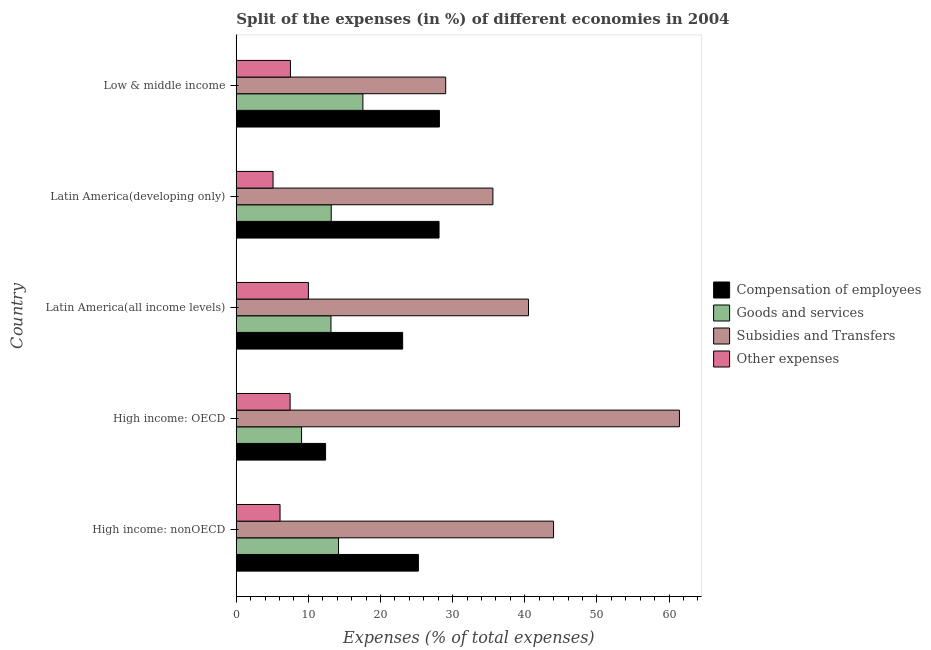How many different coloured bars are there?
Provide a succinct answer. 4. Are the number of bars per tick equal to the number of legend labels?
Offer a terse response. Yes. Are the number of bars on each tick of the Y-axis equal?
Your answer should be compact. Yes. How many bars are there on the 2nd tick from the bottom?
Keep it short and to the point. 4. What is the label of the 3rd group of bars from the top?
Your answer should be very brief. Latin America(all income levels). In how many cases, is the number of bars for a given country not equal to the number of legend labels?
Offer a very short reply. 0. What is the percentage of amount spent on compensation of employees in Low & middle income?
Offer a very short reply. 28.17. Across all countries, what is the maximum percentage of amount spent on compensation of employees?
Your answer should be compact. 28.17. Across all countries, what is the minimum percentage of amount spent on goods and services?
Ensure brevity in your answer.  9.05. In which country was the percentage of amount spent on compensation of employees minimum?
Your answer should be compact. High income: OECD. What is the total percentage of amount spent on goods and services in the graph?
Offer a very short reply. 67.09. What is the difference between the percentage of amount spent on goods and services in High income: OECD and that in Latin America(developing only)?
Offer a very short reply. -4.11. What is the difference between the percentage of amount spent on subsidies in High income: OECD and the percentage of amount spent on goods and services in Latin America(all income levels)?
Provide a short and direct response. 48.31. What is the average percentage of amount spent on compensation of employees per country?
Ensure brevity in your answer.  23.4. What is the difference between the percentage of amount spent on other expenses and percentage of amount spent on compensation of employees in High income: OECD?
Make the answer very short. -4.92. In how many countries, is the percentage of amount spent on other expenses greater than 52 %?
Your answer should be very brief. 0. What is the ratio of the percentage of amount spent on subsidies in High income: OECD to that in High income: nonOECD?
Offer a terse response. 1.4. What is the difference between the highest and the second highest percentage of amount spent on other expenses?
Make the answer very short. 2.49. What is the difference between the highest and the lowest percentage of amount spent on compensation of employees?
Keep it short and to the point. 15.78. In how many countries, is the percentage of amount spent on other expenses greater than the average percentage of amount spent on other expenses taken over all countries?
Your response must be concise. 3. Is it the case that in every country, the sum of the percentage of amount spent on subsidies and percentage of amount spent on compensation of employees is greater than the sum of percentage of amount spent on goods and services and percentage of amount spent on other expenses?
Provide a short and direct response. Yes. What does the 3rd bar from the top in Low & middle income represents?
Provide a succinct answer. Goods and services. What does the 2nd bar from the bottom in High income: nonOECD represents?
Make the answer very short. Goods and services. Are all the bars in the graph horizontal?
Provide a short and direct response. Yes. What is the difference between two consecutive major ticks on the X-axis?
Your response must be concise. 10. Are the values on the major ticks of X-axis written in scientific E-notation?
Ensure brevity in your answer.  No. Does the graph contain any zero values?
Provide a short and direct response. No. Does the graph contain grids?
Your response must be concise. No. Where does the legend appear in the graph?
Ensure brevity in your answer.  Center right. How many legend labels are there?
Make the answer very short. 4. How are the legend labels stacked?
Offer a very short reply. Vertical. What is the title of the graph?
Provide a short and direct response. Split of the expenses (in %) of different economies in 2004. Does "UNDP" appear as one of the legend labels in the graph?
Your response must be concise. No. What is the label or title of the X-axis?
Your answer should be compact. Expenses (% of total expenses). What is the Expenses (% of total expenses) in Compensation of employees in High income: nonOECD?
Make the answer very short. 25.25. What is the Expenses (% of total expenses) of Goods and services in High income: nonOECD?
Provide a short and direct response. 14.18. What is the Expenses (% of total expenses) in Subsidies and Transfers in High income: nonOECD?
Ensure brevity in your answer.  43.99. What is the Expenses (% of total expenses) of Other expenses in High income: nonOECD?
Offer a very short reply. 6.07. What is the Expenses (% of total expenses) of Compensation of employees in High income: OECD?
Ensure brevity in your answer.  12.39. What is the Expenses (% of total expenses) in Goods and services in High income: OECD?
Make the answer very short. 9.05. What is the Expenses (% of total expenses) in Subsidies and Transfers in High income: OECD?
Offer a terse response. 61.44. What is the Expenses (% of total expenses) in Other expenses in High income: OECD?
Make the answer very short. 7.47. What is the Expenses (% of total expenses) of Compensation of employees in Latin America(all income levels)?
Your answer should be compact. 23.07. What is the Expenses (% of total expenses) of Goods and services in Latin America(all income levels)?
Offer a terse response. 13.13. What is the Expenses (% of total expenses) in Subsidies and Transfers in Latin America(all income levels)?
Give a very brief answer. 40.52. What is the Expenses (% of total expenses) in Other expenses in Latin America(all income levels)?
Give a very brief answer. 10. What is the Expenses (% of total expenses) in Compensation of employees in Latin America(developing only)?
Your answer should be very brief. 28.12. What is the Expenses (% of total expenses) in Goods and services in Latin America(developing only)?
Offer a very short reply. 13.17. What is the Expenses (% of total expenses) in Subsidies and Transfers in Latin America(developing only)?
Your response must be concise. 35.58. What is the Expenses (% of total expenses) of Other expenses in Latin America(developing only)?
Give a very brief answer. 5.1. What is the Expenses (% of total expenses) in Compensation of employees in Low & middle income?
Ensure brevity in your answer.  28.17. What is the Expenses (% of total expenses) in Goods and services in Low & middle income?
Your answer should be very brief. 17.56. What is the Expenses (% of total expenses) in Subsidies and Transfers in Low & middle income?
Your response must be concise. 29.04. What is the Expenses (% of total expenses) of Other expenses in Low & middle income?
Provide a succinct answer. 7.51. Across all countries, what is the maximum Expenses (% of total expenses) in Compensation of employees?
Provide a succinct answer. 28.17. Across all countries, what is the maximum Expenses (% of total expenses) of Goods and services?
Provide a short and direct response. 17.56. Across all countries, what is the maximum Expenses (% of total expenses) in Subsidies and Transfers?
Provide a short and direct response. 61.44. Across all countries, what is the maximum Expenses (% of total expenses) of Other expenses?
Your answer should be compact. 10. Across all countries, what is the minimum Expenses (% of total expenses) of Compensation of employees?
Your answer should be compact. 12.39. Across all countries, what is the minimum Expenses (% of total expenses) of Goods and services?
Your response must be concise. 9.05. Across all countries, what is the minimum Expenses (% of total expenses) of Subsidies and Transfers?
Your answer should be compact. 29.04. Across all countries, what is the minimum Expenses (% of total expenses) of Other expenses?
Offer a terse response. 5.1. What is the total Expenses (% of total expenses) of Compensation of employees in the graph?
Your answer should be very brief. 116.99. What is the total Expenses (% of total expenses) in Goods and services in the graph?
Keep it short and to the point. 67.09. What is the total Expenses (% of total expenses) of Subsidies and Transfers in the graph?
Provide a short and direct response. 210.57. What is the total Expenses (% of total expenses) of Other expenses in the graph?
Keep it short and to the point. 36.16. What is the difference between the Expenses (% of total expenses) in Compensation of employees in High income: nonOECD and that in High income: OECD?
Your answer should be very brief. 12.87. What is the difference between the Expenses (% of total expenses) of Goods and services in High income: nonOECD and that in High income: OECD?
Keep it short and to the point. 5.12. What is the difference between the Expenses (% of total expenses) of Subsidies and Transfers in High income: nonOECD and that in High income: OECD?
Give a very brief answer. -17.45. What is the difference between the Expenses (% of total expenses) of Other expenses in High income: nonOECD and that in High income: OECD?
Give a very brief answer. -1.4. What is the difference between the Expenses (% of total expenses) of Compensation of employees in High income: nonOECD and that in Latin America(all income levels)?
Your response must be concise. 2.18. What is the difference between the Expenses (% of total expenses) of Goods and services in High income: nonOECD and that in Latin America(all income levels)?
Offer a terse response. 1.05. What is the difference between the Expenses (% of total expenses) in Subsidies and Transfers in High income: nonOECD and that in Latin America(all income levels)?
Ensure brevity in your answer.  3.47. What is the difference between the Expenses (% of total expenses) of Other expenses in High income: nonOECD and that in Latin America(all income levels)?
Give a very brief answer. -3.93. What is the difference between the Expenses (% of total expenses) in Compensation of employees in High income: nonOECD and that in Latin America(developing only)?
Keep it short and to the point. -2.86. What is the difference between the Expenses (% of total expenses) in Goods and services in High income: nonOECD and that in Latin America(developing only)?
Ensure brevity in your answer.  1.01. What is the difference between the Expenses (% of total expenses) of Subsidies and Transfers in High income: nonOECD and that in Latin America(developing only)?
Provide a succinct answer. 8.41. What is the difference between the Expenses (% of total expenses) of Other expenses in High income: nonOECD and that in Latin America(developing only)?
Make the answer very short. 0.97. What is the difference between the Expenses (% of total expenses) in Compensation of employees in High income: nonOECD and that in Low & middle income?
Your response must be concise. -2.91. What is the difference between the Expenses (% of total expenses) of Goods and services in High income: nonOECD and that in Low & middle income?
Keep it short and to the point. -3.38. What is the difference between the Expenses (% of total expenses) in Subsidies and Transfers in High income: nonOECD and that in Low & middle income?
Make the answer very short. 14.95. What is the difference between the Expenses (% of total expenses) of Other expenses in High income: nonOECD and that in Low & middle income?
Your answer should be very brief. -1.44. What is the difference between the Expenses (% of total expenses) of Compensation of employees in High income: OECD and that in Latin America(all income levels)?
Keep it short and to the point. -10.69. What is the difference between the Expenses (% of total expenses) in Goods and services in High income: OECD and that in Latin America(all income levels)?
Ensure brevity in your answer.  -4.08. What is the difference between the Expenses (% of total expenses) in Subsidies and Transfers in High income: OECD and that in Latin America(all income levels)?
Your response must be concise. 20.93. What is the difference between the Expenses (% of total expenses) of Other expenses in High income: OECD and that in Latin America(all income levels)?
Keep it short and to the point. -2.53. What is the difference between the Expenses (% of total expenses) in Compensation of employees in High income: OECD and that in Latin America(developing only)?
Your answer should be very brief. -15.73. What is the difference between the Expenses (% of total expenses) in Goods and services in High income: OECD and that in Latin America(developing only)?
Ensure brevity in your answer.  -4.11. What is the difference between the Expenses (% of total expenses) in Subsidies and Transfers in High income: OECD and that in Latin America(developing only)?
Offer a very short reply. 25.86. What is the difference between the Expenses (% of total expenses) of Other expenses in High income: OECD and that in Latin America(developing only)?
Ensure brevity in your answer.  2.37. What is the difference between the Expenses (% of total expenses) in Compensation of employees in High income: OECD and that in Low & middle income?
Keep it short and to the point. -15.78. What is the difference between the Expenses (% of total expenses) of Goods and services in High income: OECD and that in Low & middle income?
Offer a terse response. -8.5. What is the difference between the Expenses (% of total expenses) of Subsidies and Transfers in High income: OECD and that in Low & middle income?
Provide a succinct answer. 32.41. What is the difference between the Expenses (% of total expenses) of Other expenses in High income: OECD and that in Low & middle income?
Provide a succinct answer. -0.04. What is the difference between the Expenses (% of total expenses) of Compensation of employees in Latin America(all income levels) and that in Latin America(developing only)?
Provide a succinct answer. -5.04. What is the difference between the Expenses (% of total expenses) in Goods and services in Latin America(all income levels) and that in Latin America(developing only)?
Offer a terse response. -0.04. What is the difference between the Expenses (% of total expenses) in Subsidies and Transfers in Latin America(all income levels) and that in Latin America(developing only)?
Your response must be concise. 4.94. What is the difference between the Expenses (% of total expenses) in Other expenses in Latin America(all income levels) and that in Latin America(developing only)?
Your answer should be compact. 4.9. What is the difference between the Expenses (% of total expenses) of Compensation of employees in Latin America(all income levels) and that in Low & middle income?
Your answer should be compact. -5.09. What is the difference between the Expenses (% of total expenses) in Goods and services in Latin America(all income levels) and that in Low & middle income?
Your answer should be compact. -4.43. What is the difference between the Expenses (% of total expenses) in Subsidies and Transfers in Latin America(all income levels) and that in Low & middle income?
Your answer should be very brief. 11.48. What is the difference between the Expenses (% of total expenses) of Other expenses in Latin America(all income levels) and that in Low & middle income?
Offer a very short reply. 2.49. What is the difference between the Expenses (% of total expenses) in Compensation of employees in Latin America(developing only) and that in Low & middle income?
Your answer should be compact. -0.05. What is the difference between the Expenses (% of total expenses) in Goods and services in Latin America(developing only) and that in Low & middle income?
Your answer should be very brief. -4.39. What is the difference between the Expenses (% of total expenses) in Subsidies and Transfers in Latin America(developing only) and that in Low & middle income?
Offer a very short reply. 6.55. What is the difference between the Expenses (% of total expenses) in Other expenses in Latin America(developing only) and that in Low & middle income?
Your answer should be very brief. -2.41. What is the difference between the Expenses (% of total expenses) of Compensation of employees in High income: nonOECD and the Expenses (% of total expenses) of Goods and services in High income: OECD?
Your answer should be compact. 16.2. What is the difference between the Expenses (% of total expenses) in Compensation of employees in High income: nonOECD and the Expenses (% of total expenses) in Subsidies and Transfers in High income: OECD?
Ensure brevity in your answer.  -36.19. What is the difference between the Expenses (% of total expenses) in Compensation of employees in High income: nonOECD and the Expenses (% of total expenses) in Other expenses in High income: OECD?
Provide a succinct answer. 17.78. What is the difference between the Expenses (% of total expenses) in Goods and services in High income: nonOECD and the Expenses (% of total expenses) in Subsidies and Transfers in High income: OECD?
Your answer should be compact. -47.27. What is the difference between the Expenses (% of total expenses) of Goods and services in High income: nonOECD and the Expenses (% of total expenses) of Other expenses in High income: OECD?
Your response must be concise. 6.71. What is the difference between the Expenses (% of total expenses) in Subsidies and Transfers in High income: nonOECD and the Expenses (% of total expenses) in Other expenses in High income: OECD?
Give a very brief answer. 36.52. What is the difference between the Expenses (% of total expenses) in Compensation of employees in High income: nonOECD and the Expenses (% of total expenses) in Goods and services in Latin America(all income levels)?
Offer a terse response. 12.12. What is the difference between the Expenses (% of total expenses) of Compensation of employees in High income: nonOECD and the Expenses (% of total expenses) of Subsidies and Transfers in Latin America(all income levels)?
Provide a succinct answer. -15.27. What is the difference between the Expenses (% of total expenses) in Compensation of employees in High income: nonOECD and the Expenses (% of total expenses) in Other expenses in Latin America(all income levels)?
Make the answer very short. 15.25. What is the difference between the Expenses (% of total expenses) in Goods and services in High income: nonOECD and the Expenses (% of total expenses) in Subsidies and Transfers in Latin America(all income levels)?
Your answer should be compact. -26.34. What is the difference between the Expenses (% of total expenses) of Goods and services in High income: nonOECD and the Expenses (% of total expenses) of Other expenses in Latin America(all income levels)?
Your response must be concise. 4.18. What is the difference between the Expenses (% of total expenses) in Subsidies and Transfers in High income: nonOECD and the Expenses (% of total expenses) in Other expenses in Latin America(all income levels)?
Keep it short and to the point. 33.99. What is the difference between the Expenses (% of total expenses) of Compensation of employees in High income: nonOECD and the Expenses (% of total expenses) of Goods and services in Latin America(developing only)?
Keep it short and to the point. 12.08. What is the difference between the Expenses (% of total expenses) in Compensation of employees in High income: nonOECD and the Expenses (% of total expenses) in Subsidies and Transfers in Latin America(developing only)?
Your response must be concise. -10.33. What is the difference between the Expenses (% of total expenses) of Compensation of employees in High income: nonOECD and the Expenses (% of total expenses) of Other expenses in Latin America(developing only)?
Provide a short and direct response. 20.15. What is the difference between the Expenses (% of total expenses) of Goods and services in High income: nonOECD and the Expenses (% of total expenses) of Subsidies and Transfers in Latin America(developing only)?
Make the answer very short. -21.4. What is the difference between the Expenses (% of total expenses) of Goods and services in High income: nonOECD and the Expenses (% of total expenses) of Other expenses in Latin America(developing only)?
Provide a succinct answer. 9.08. What is the difference between the Expenses (% of total expenses) of Subsidies and Transfers in High income: nonOECD and the Expenses (% of total expenses) of Other expenses in Latin America(developing only)?
Your answer should be very brief. 38.89. What is the difference between the Expenses (% of total expenses) in Compensation of employees in High income: nonOECD and the Expenses (% of total expenses) in Goods and services in Low & middle income?
Your answer should be compact. 7.69. What is the difference between the Expenses (% of total expenses) in Compensation of employees in High income: nonOECD and the Expenses (% of total expenses) in Subsidies and Transfers in Low & middle income?
Make the answer very short. -3.79. What is the difference between the Expenses (% of total expenses) in Compensation of employees in High income: nonOECD and the Expenses (% of total expenses) in Other expenses in Low & middle income?
Give a very brief answer. 17.74. What is the difference between the Expenses (% of total expenses) of Goods and services in High income: nonOECD and the Expenses (% of total expenses) of Subsidies and Transfers in Low & middle income?
Ensure brevity in your answer.  -14.86. What is the difference between the Expenses (% of total expenses) of Goods and services in High income: nonOECD and the Expenses (% of total expenses) of Other expenses in Low & middle income?
Your response must be concise. 6.67. What is the difference between the Expenses (% of total expenses) of Subsidies and Transfers in High income: nonOECD and the Expenses (% of total expenses) of Other expenses in Low & middle income?
Offer a terse response. 36.48. What is the difference between the Expenses (% of total expenses) in Compensation of employees in High income: OECD and the Expenses (% of total expenses) in Goods and services in Latin America(all income levels)?
Give a very brief answer. -0.75. What is the difference between the Expenses (% of total expenses) of Compensation of employees in High income: OECD and the Expenses (% of total expenses) of Subsidies and Transfers in Latin America(all income levels)?
Your answer should be compact. -28.13. What is the difference between the Expenses (% of total expenses) of Compensation of employees in High income: OECD and the Expenses (% of total expenses) of Other expenses in Latin America(all income levels)?
Your response must be concise. 2.38. What is the difference between the Expenses (% of total expenses) in Goods and services in High income: OECD and the Expenses (% of total expenses) in Subsidies and Transfers in Latin America(all income levels)?
Your answer should be very brief. -31.46. What is the difference between the Expenses (% of total expenses) in Goods and services in High income: OECD and the Expenses (% of total expenses) in Other expenses in Latin America(all income levels)?
Keep it short and to the point. -0.95. What is the difference between the Expenses (% of total expenses) of Subsidies and Transfers in High income: OECD and the Expenses (% of total expenses) of Other expenses in Latin America(all income levels)?
Provide a succinct answer. 51.44. What is the difference between the Expenses (% of total expenses) in Compensation of employees in High income: OECD and the Expenses (% of total expenses) in Goods and services in Latin America(developing only)?
Your response must be concise. -0.78. What is the difference between the Expenses (% of total expenses) in Compensation of employees in High income: OECD and the Expenses (% of total expenses) in Subsidies and Transfers in Latin America(developing only)?
Provide a succinct answer. -23.2. What is the difference between the Expenses (% of total expenses) of Compensation of employees in High income: OECD and the Expenses (% of total expenses) of Other expenses in Latin America(developing only)?
Offer a very short reply. 7.28. What is the difference between the Expenses (% of total expenses) of Goods and services in High income: OECD and the Expenses (% of total expenses) of Subsidies and Transfers in Latin America(developing only)?
Offer a terse response. -26.53. What is the difference between the Expenses (% of total expenses) of Goods and services in High income: OECD and the Expenses (% of total expenses) of Other expenses in Latin America(developing only)?
Your response must be concise. 3.95. What is the difference between the Expenses (% of total expenses) of Subsidies and Transfers in High income: OECD and the Expenses (% of total expenses) of Other expenses in Latin America(developing only)?
Your response must be concise. 56.34. What is the difference between the Expenses (% of total expenses) of Compensation of employees in High income: OECD and the Expenses (% of total expenses) of Goods and services in Low & middle income?
Provide a succinct answer. -5.17. What is the difference between the Expenses (% of total expenses) in Compensation of employees in High income: OECD and the Expenses (% of total expenses) in Subsidies and Transfers in Low & middle income?
Provide a short and direct response. -16.65. What is the difference between the Expenses (% of total expenses) of Compensation of employees in High income: OECD and the Expenses (% of total expenses) of Other expenses in Low & middle income?
Provide a short and direct response. 4.87. What is the difference between the Expenses (% of total expenses) in Goods and services in High income: OECD and the Expenses (% of total expenses) in Subsidies and Transfers in Low & middle income?
Your answer should be compact. -19.98. What is the difference between the Expenses (% of total expenses) of Goods and services in High income: OECD and the Expenses (% of total expenses) of Other expenses in Low & middle income?
Your answer should be very brief. 1.54. What is the difference between the Expenses (% of total expenses) in Subsidies and Transfers in High income: OECD and the Expenses (% of total expenses) in Other expenses in Low & middle income?
Keep it short and to the point. 53.93. What is the difference between the Expenses (% of total expenses) in Compensation of employees in Latin America(all income levels) and the Expenses (% of total expenses) in Goods and services in Latin America(developing only)?
Ensure brevity in your answer.  9.9. What is the difference between the Expenses (% of total expenses) in Compensation of employees in Latin America(all income levels) and the Expenses (% of total expenses) in Subsidies and Transfers in Latin America(developing only)?
Provide a short and direct response. -12.51. What is the difference between the Expenses (% of total expenses) of Compensation of employees in Latin America(all income levels) and the Expenses (% of total expenses) of Other expenses in Latin America(developing only)?
Keep it short and to the point. 17.97. What is the difference between the Expenses (% of total expenses) of Goods and services in Latin America(all income levels) and the Expenses (% of total expenses) of Subsidies and Transfers in Latin America(developing only)?
Keep it short and to the point. -22.45. What is the difference between the Expenses (% of total expenses) of Goods and services in Latin America(all income levels) and the Expenses (% of total expenses) of Other expenses in Latin America(developing only)?
Offer a very short reply. 8.03. What is the difference between the Expenses (% of total expenses) in Subsidies and Transfers in Latin America(all income levels) and the Expenses (% of total expenses) in Other expenses in Latin America(developing only)?
Offer a very short reply. 35.42. What is the difference between the Expenses (% of total expenses) in Compensation of employees in Latin America(all income levels) and the Expenses (% of total expenses) in Goods and services in Low & middle income?
Provide a short and direct response. 5.51. What is the difference between the Expenses (% of total expenses) of Compensation of employees in Latin America(all income levels) and the Expenses (% of total expenses) of Subsidies and Transfers in Low & middle income?
Provide a succinct answer. -5.97. What is the difference between the Expenses (% of total expenses) in Compensation of employees in Latin America(all income levels) and the Expenses (% of total expenses) in Other expenses in Low & middle income?
Ensure brevity in your answer.  15.56. What is the difference between the Expenses (% of total expenses) in Goods and services in Latin America(all income levels) and the Expenses (% of total expenses) in Subsidies and Transfers in Low & middle income?
Your answer should be very brief. -15.91. What is the difference between the Expenses (% of total expenses) in Goods and services in Latin America(all income levels) and the Expenses (% of total expenses) in Other expenses in Low & middle income?
Provide a short and direct response. 5.62. What is the difference between the Expenses (% of total expenses) in Subsidies and Transfers in Latin America(all income levels) and the Expenses (% of total expenses) in Other expenses in Low & middle income?
Keep it short and to the point. 33.01. What is the difference between the Expenses (% of total expenses) of Compensation of employees in Latin America(developing only) and the Expenses (% of total expenses) of Goods and services in Low & middle income?
Offer a very short reply. 10.56. What is the difference between the Expenses (% of total expenses) in Compensation of employees in Latin America(developing only) and the Expenses (% of total expenses) in Subsidies and Transfers in Low & middle income?
Your response must be concise. -0.92. What is the difference between the Expenses (% of total expenses) in Compensation of employees in Latin America(developing only) and the Expenses (% of total expenses) in Other expenses in Low & middle income?
Ensure brevity in your answer.  20.6. What is the difference between the Expenses (% of total expenses) of Goods and services in Latin America(developing only) and the Expenses (% of total expenses) of Subsidies and Transfers in Low & middle income?
Provide a short and direct response. -15.87. What is the difference between the Expenses (% of total expenses) of Goods and services in Latin America(developing only) and the Expenses (% of total expenses) of Other expenses in Low & middle income?
Ensure brevity in your answer.  5.66. What is the difference between the Expenses (% of total expenses) in Subsidies and Transfers in Latin America(developing only) and the Expenses (% of total expenses) in Other expenses in Low & middle income?
Offer a very short reply. 28.07. What is the average Expenses (% of total expenses) in Compensation of employees per country?
Keep it short and to the point. 23.4. What is the average Expenses (% of total expenses) of Goods and services per country?
Your answer should be compact. 13.42. What is the average Expenses (% of total expenses) in Subsidies and Transfers per country?
Ensure brevity in your answer.  42.11. What is the average Expenses (% of total expenses) of Other expenses per country?
Keep it short and to the point. 7.23. What is the difference between the Expenses (% of total expenses) of Compensation of employees and Expenses (% of total expenses) of Goods and services in High income: nonOECD?
Offer a terse response. 11.07. What is the difference between the Expenses (% of total expenses) of Compensation of employees and Expenses (% of total expenses) of Subsidies and Transfers in High income: nonOECD?
Provide a short and direct response. -18.74. What is the difference between the Expenses (% of total expenses) in Compensation of employees and Expenses (% of total expenses) in Other expenses in High income: nonOECD?
Your response must be concise. 19.18. What is the difference between the Expenses (% of total expenses) of Goods and services and Expenses (% of total expenses) of Subsidies and Transfers in High income: nonOECD?
Provide a succinct answer. -29.81. What is the difference between the Expenses (% of total expenses) in Goods and services and Expenses (% of total expenses) in Other expenses in High income: nonOECD?
Offer a very short reply. 8.11. What is the difference between the Expenses (% of total expenses) of Subsidies and Transfers and Expenses (% of total expenses) of Other expenses in High income: nonOECD?
Give a very brief answer. 37.92. What is the difference between the Expenses (% of total expenses) of Compensation of employees and Expenses (% of total expenses) of Goods and services in High income: OECD?
Your answer should be very brief. 3.33. What is the difference between the Expenses (% of total expenses) of Compensation of employees and Expenses (% of total expenses) of Subsidies and Transfers in High income: OECD?
Your answer should be very brief. -49.06. What is the difference between the Expenses (% of total expenses) of Compensation of employees and Expenses (% of total expenses) of Other expenses in High income: OECD?
Offer a very short reply. 4.92. What is the difference between the Expenses (% of total expenses) in Goods and services and Expenses (% of total expenses) in Subsidies and Transfers in High income: OECD?
Provide a succinct answer. -52.39. What is the difference between the Expenses (% of total expenses) in Goods and services and Expenses (% of total expenses) in Other expenses in High income: OECD?
Provide a succinct answer. 1.59. What is the difference between the Expenses (% of total expenses) of Subsidies and Transfers and Expenses (% of total expenses) of Other expenses in High income: OECD?
Your answer should be very brief. 53.98. What is the difference between the Expenses (% of total expenses) in Compensation of employees and Expenses (% of total expenses) in Goods and services in Latin America(all income levels)?
Offer a very short reply. 9.94. What is the difference between the Expenses (% of total expenses) in Compensation of employees and Expenses (% of total expenses) in Subsidies and Transfers in Latin America(all income levels)?
Provide a succinct answer. -17.45. What is the difference between the Expenses (% of total expenses) of Compensation of employees and Expenses (% of total expenses) of Other expenses in Latin America(all income levels)?
Offer a very short reply. 13.07. What is the difference between the Expenses (% of total expenses) in Goods and services and Expenses (% of total expenses) in Subsidies and Transfers in Latin America(all income levels)?
Your response must be concise. -27.39. What is the difference between the Expenses (% of total expenses) in Goods and services and Expenses (% of total expenses) in Other expenses in Latin America(all income levels)?
Offer a very short reply. 3.13. What is the difference between the Expenses (% of total expenses) of Subsidies and Transfers and Expenses (% of total expenses) of Other expenses in Latin America(all income levels)?
Your answer should be very brief. 30.52. What is the difference between the Expenses (% of total expenses) in Compensation of employees and Expenses (% of total expenses) in Goods and services in Latin America(developing only)?
Your response must be concise. 14.95. What is the difference between the Expenses (% of total expenses) in Compensation of employees and Expenses (% of total expenses) in Subsidies and Transfers in Latin America(developing only)?
Ensure brevity in your answer.  -7.47. What is the difference between the Expenses (% of total expenses) in Compensation of employees and Expenses (% of total expenses) in Other expenses in Latin America(developing only)?
Your answer should be compact. 23.01. What is the difference between the Expenses (% of total expenses) of Goods and services and Expenses (% of total expenses) of Subsidies and Transfers in Latin America(developing only)?
Provide a succinct answer. -22.41. What is the difference between the Expenses (% of total expenses) in Goods and services and Expenses (% of total expenses) in Other expenses in Latin America(developing only)?
Provide a succinct answer. 8.07. What is the difference between the Expenses (% of total expenses) of Subsidies and Transfers and Expenses (% of total expenses) of Other expenses in Latin America(developing only)?
Your answer should be very brief. 30.48. What is the difference between the Expenses (% of total expenses) of Compensation of employees and Expenses (% of total expenses) of Goods and services in Low & middle income?
Offer a very short reply. 10.61. What is the difference between the Expenses (% of total expenses) of Compensation of employees and Expenses (% of total expenses) of Subsidies and Transfers in Low & middle income?
Offer a terse response. -0.87. What is the difference between the Expenses (% of total expenses) of Compensation of employees and Expenses (% of total expenses) of Other expenses in Low & middle income?
Offer a very short reply. 20.65. What is the difference between the Expenses (% of total expenses) of Goods and services and Expenses (% of total expenses) of Subsidies and Transfers in Low & middle income?
Your answer should be very brief. -11.48. What is the difference between the Expenses (% of total expenses) of Goods and services and Expenses (% of total expenses) of Other expenses in Low & middle income?
Your answer should be very brief. 10.05. What is the difference between the Expenses (% of total expenses) of Subsidies and Transfers and Expenses (% of total expenses) of Other expenses in Low & middle income?
Provide a succinct answer. 21.52. What is the ratio of the Expenses (% of total expenses) in Compensation of employees in High income: nonOECD to that in High income: OECD?
Offer a terse response. 2.04. What is the ratio of the Expenses (% of total expenses) of Goods and services in High income: nonOECD to that in High income: OECD?
Your response must be concise. 1.57. What is the ratio of the Expenses (% of total expenses) in Subsidies and Transfers in High income: nonOECD to that in High income: OECD?
Offer a terse response. 0.72. What is the ratio of the Expenses (% of total expenses) of Other expenses in High income: nonOECD to that in High income: OECD?
Keep it short and to the point. 0.81. What is the ratio of the Expenses (% of total expenses) of Compensation of employees in High income: nonOECD to that in Latin America(all income levels)?
Give a very brief answer. 1.09. What is the ratio of the Expenses (% of total expenses) in Goods and services in High income: nonOECD to that in Latin America(all income levels)?
Provide a short and direct response. 1.08. What is the ratio of the Expenses (% of total expenses) in Subsidies and Transfers in High income: nonOECD to that in Latin America(all income levels)?
Offer a terse response. 1.09. What is the ratio of the Expenses (% of total expenses) of Other expenses in High income: nonOECD to that in Latin America(all income levels)?
Make the answer very short. 0.61. What is the ratio of the Expenses (% of total expenses) in Compensation of employees in High income: nonOECD to that in Latin America(developing only)?
Your response must be concise. 0.9. What is the ratio of the Expenses (% of total expenses) of Goods and services in High income: nonOECD to that in Latin America(developing only)?
Make the answer very short. 1.08. What is the ratio of the Expenses (% of total expenses) in Subsidies and Transfers in High income: nonOECD to that in Latin America(developing only)?
Ensure brevity in your answer.  1.24. What is the ratio of the Expenses (% of total expenses) of Other expenses in High income: nonOECD to that in Latin America(developing only)?
Your answer should be very brief. 1.19. What is the ratio of the Expenses (% of total expenses) in Compensation of employees in High income: nonOECD to that in Low & middle income?
Your response must be concise. 0.9. What is the ratio of the Expenses (% of total expenses) of Goods and services in High income: nonOECD to that in Low & middle income?
Make the answer very short. 0.81. What is the ratio of the Expenses (% of total expenses) in Subsidies and Transfers in High income: nonOECD to that in Low & middle income?
Provide a succinct answer. 1.51. What is the ratio of the Expenses (% of total expenses) in Other expenses in High income: nonOECD to that in Low & middle income?
Ensure brevity in your answer.  0.81. What is the ratio of the Expenses (% of total expenses) of Compensation of employees in High income: OECD to that in Latin America(all income levels)?
Ensure brevity in your answer.  0.54. What is the ratio of the Expenses (% of total expenses) in Goods and services in High income: OECD to that in Latin America(all income levels)?
Make the answer very short. 0.69. What is the ratio of the Expenses (% of total expenses) in Subsidies and Transfers in High income: OECD to that in Latin America(all income levels)?
Give a very brief answer. 1.52. What is the ratio of the Expenses (% of total expenses) of Other expenses in High income: OECD to that in Latin America(all income levels)?
Ensure brevity in your answer.  0.75. What is the ratio of the Expenses (% of total expenses) in Compensation of employees in High income: OECD to that in Latin America(developing only)?
Make the answer very short. 0.44. What is the ratio of the Expenses (% of total expenses) of Goods and services in High income: OECD to that in Latin America(developing only)?
Provide a short and direct response. 0.69. What is the ratio of the Expenses (% of total expenses) of Subsidies and Transfers in High income: OECD to that in Latin America(developing only)?
Ensure brevity in your answer.  1.73. What is the ratio of the Expenses (% of total expenses) of Other expenses in High income: OECD to that in Latin America(developing only)?
Your answer should be compact. 1.46. What is the ratio of the Expenses (% of total expenses) of Compensation of employees in High income: OECD to that in Low & middle income?
Make the answer very short. 0.44. What is the ratio of the Expenses (% of total expenses) in Goods and services in High income: OECD to that in Low & middle income?
Your response must be concise. 0.52. What is the ratio of the Expenses (% of total expenses) of Subsidies and Transfers in High income: OECD to that in Low & middle income?
Your answer should be compact. 2.12. What is the ratio of the Expenses (% of total expenses) in Compensation of employees in Latin America(all income levels) to that in Latin America(developing only)?
Offer a very short reply. 0.82. What is the ratio of the Expenses (% of total expenses) of Goods and services in Latin America(all income levels) to that in Latin America(developing only)?
Offer a terse response. 1. What is the ratio of the Expenses (% of total expenses) of Subsidies and Transfers in Latin America(all income levels) to that in Latin America(developing only)?
Keep it short and to the point. 1.14. What is the ratio of the Expenses (% of total expenses) of Other expenses in Latin America(all income levels) to that in Latin America(developing only)?
Ensure brevity in your answer.  1.96. What is the ratio of the Expenses (% of total expenses) in Compensation of employees in Latin America(all income levels) to that in Low & middle income?
Offer a terse response. 0.82. What is the ratio of the Expenses (% of total expenses) of Goods and services in Latin America(all income levels) to that in Low & middle income?
Your response must be concise. 0.75. What is the ratio of the Expenses (% of total expenses) in Subsidies and Transfers in Latin America(all income levels) to that in Low & middle income?
Your answer should be very brief. 1.4. What is the ratio of the Expenses (% of total expenses) in Other expenses in Latin America(all income levels) to that in Low & middle income?
Provide a succinct answer. 1.33. What is the ratio of the Expenses (% of total expenses) in Compensation of employees in Latin America(developing only) to that in Low & middle income?
Keep it short and to the point. 1. What is the ratio of the Expenses (% of total expenses) in Goods and services in Latin America(developing only) to that in Low & middle income?
Provide a short and direct response. 0.75. What is the ratio of the Expenses (% of total expenses) of Subsidies and Transfers in Latin America(developing only) to that in Low & middle income?
Your response must be concise. 1.23. What is the ratio of the Expenses (% of total expenses) in Other expenses in Latin America(developing only) to that in Low & middle income?
Your response must be concise. 0.68. What is the difference between the highest and the second highest Expenses (% of total expenses) of Compensation of employees?
Ensure brevity in your answer.  0.05. What is the difference between the highest and the second highest Expenses (% of total expenses) of Goods and services?
Your answer should be very brief. 3.38. What is the difference between the highest and the second highest Expenses (% of total expenses) of Subsidies and Transfers?
Provide a short and direct response. 17.45. What is the difference between the highest and the second highest Expenses (% of total expenses) of Other expenses?
Offer a terse response. 2.49. What is the difference between the highest and the lowest Expenses (% of total expenses) of Compensation of employees?
Your answer should be compact. 15.78. What is the difference between the highest and the lowest Expenses (% of total expenses) in Goods and services?
Provide a succinct answer. 8.5. What is the difference between the highest and the lowest Expenses (% of total expenses) of Subsidies and Transfers?
Offer a very short reply. 32.41. What is the difference between the highest and the lowest Expenses (% of total expenses) in Other expenses?
Offer a very short reply. 4.9. 